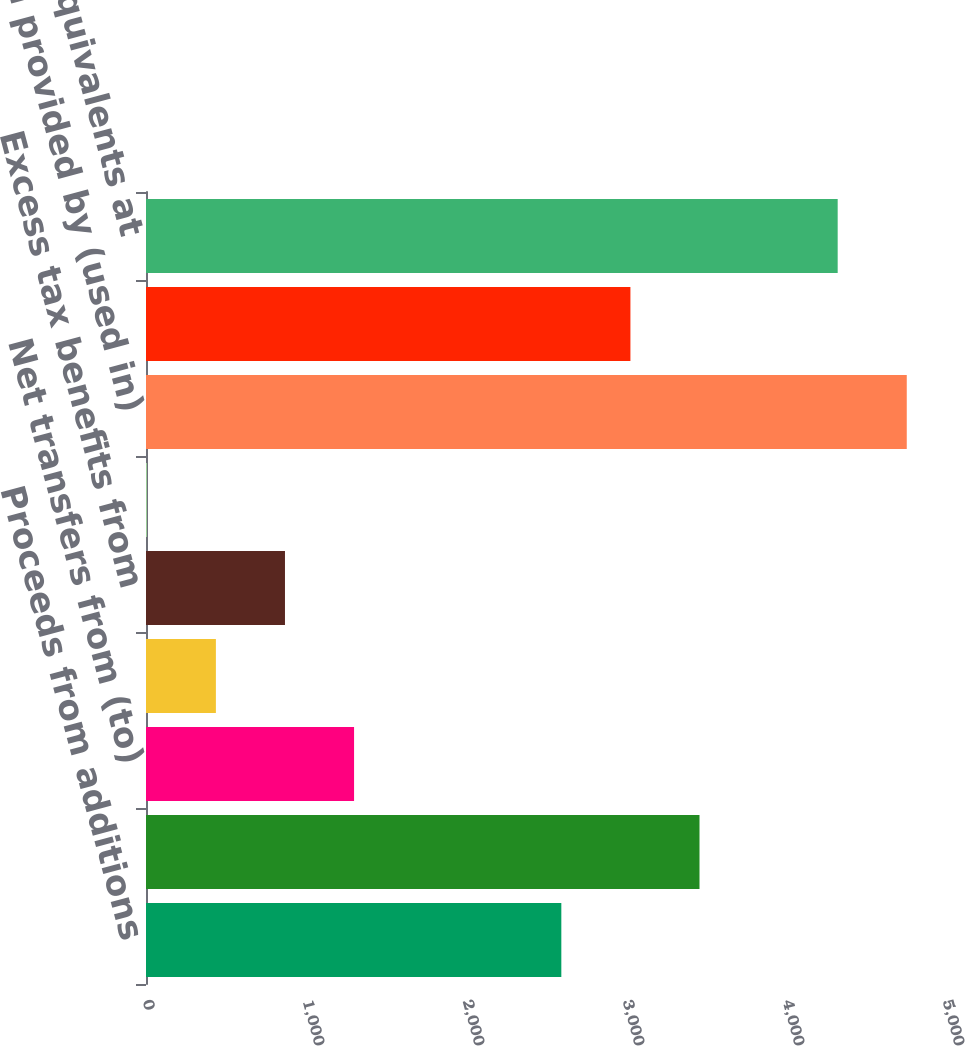Convert chart. <chart><loc_0><loc_0><loc_500><loc_500><bar_chart><fcel>Proceeds from additions<fcel>Consideration received<fcel>Net transfers from (to)<fcel>Exercise of stock options<fcel>Excess tax benefits from<fcel>Noncontrolling interests<fcel>Net cash provided by (used in)<fcel>Net (decrease) increase in<fcel>Cash and cash equivalents at<nl><fcel>2595.8<fcel>3459.4<fcel>1300.4<fcel>436.8<fcel>868.6<fcel>5<fcel>4754.8<fcel>3027.6<fcel>4323<nl></chart> 